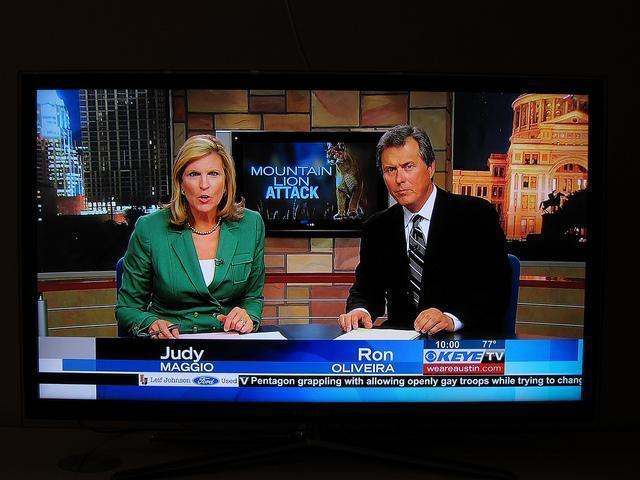How many people are there?
Give a very brief answer. 2. 